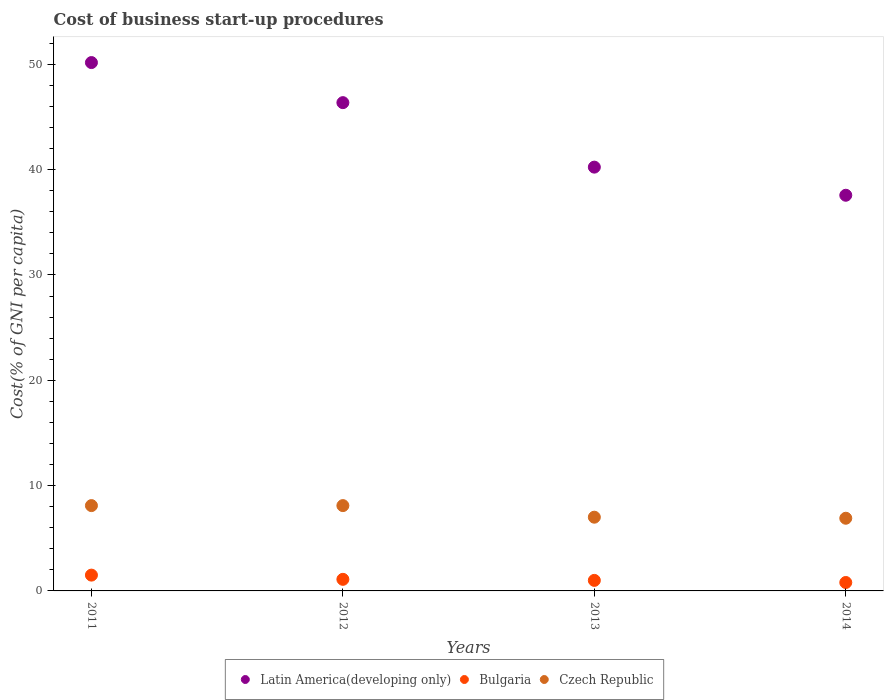Is the number of dotlines equal to the number of legend labels?
Keep it short and to the point. Yes. Across all years, what is the maximum cost of business start-up procedures in Czech Republic?
Offer a terse response. 8.1. In which year was the cost of business start-up procedures in Czech Republic maximum?
Your answer should be very brief. 2011. In which year was the cost of business start-up procedures in Latin America(developing only) minimum?
Provide a short and direct response. 2014. What is the total cost of business start-up procedures in Czech Republic in the graph?
Provide a succinct answer. 30.1. What is the difference between the cost of business start-up procedures in Bulgaria in 2013 and that in 2014?
Give a very brief answer. 0.2. What is the difference between the cost of business start-up procedures in Latin America(developing only) in 2013 and the cost of business start-up procedures in Bulgaria in 2014?
Keep it short and to the point. 39.43. What is the average cost of business start-up procedures in Czech Republic per year?
Keep it short and to the point. 7.53. In the year 2014, what is the difference between the cost of business start-up procedures in Bulgaria and cost of business start-up procedures in Latin America(developing only)?
Your response must be concise. -36.77. What is the ratio of the cost of business start-up procedures in Latin America(developing only) in 2012 to that in 2013?
Keep it short and to the point. 1.15. Is the cost of business start-up procedures in Czech Republic in 2011 less than that in 2013?
Ensure brevity in your answer.  No. Is the difference between the cost of business start-up procedures in Bulgaria in 2012 and 2014 greater than the difference between the cost of business start-up procedures in Latin America(developing only) in 2012 and 2014?
Your answer should be compact. No. What is the difference between the highest and the second highest cost of business start-up procedures in Bulgaria?
Your answer should be compact. 0.4. What is the difference between the highest and the lowest cost of business start-up procedures in Latin America(developing only)?
Your response must be concise. 12.6. In how many years, is the cost of business start-up procedures in Bulgaria greater than the average cost of business start-up procedures in Bulgaria taken over all years?
Your answer should be compact. 1. Does the cost of business start-up procedures in Bulgaria monotonically increase over the years?
Give a very brief answer. No. Is the cost of business start-up procedures in Bulgaria strictly greater than the cost of business start-up procedures in Czech Republic over the years?
Offer a very short reply. No. Is the cost of business start-up procedures in Latin America(developing only) strictly less than the cost of business start-up procedures in Bulgaria over the years?
Keep it short and to the point. No. How many dotlines are there?
Offer a very short reply. 3. How many years are there in the graph?
Ensure brevity in your answer.  4. Does the graph contain any zero values?
Your answer should be very brief. No. What is the title of the graph?
Provide a succinct answer. Cost of business start-up procedures. Does "Mauritius" appear as one of the legend labels in the graph?
Provide a short and direct response. No. What is the label or title of the X-axis?
Your answer should be compact. Years. What is the label or title of the Y-axis?
Provide a short and direct response. Cost(% of GNI per capita). What is the Cost(% of GNI per capita) in Latin America(developing only) in 2011?
Your response must be concise. 50.16. What is the Cost(% of GNI per capita) in Czech Republic in 2011?
Ensure brevity in your answer.  8.1. What is the Cost(% of GNI per capita) in Latin America(developing only) in 2012?
Offer a very short reply. 46.36. What is the Cost(% of GNI per capita) of Bulgaria in 2012?
Your response must be concise. 1.1. What is the Cost(% of GNI per capita) of Czech Republic in 2012?
Offer a terse response. 8.1. What is the Cost(% of GNI per capita) in Latin America(developing only) in 2013?
Provide a short and direct response. 40.23. What is the Cost(% of GNI per capita) in Bulgaria in 2013?
Provide a succinct answer. 1. What is the Cost(% of GNI per capita) of Latin America(developing only) in 2014?
Your response must be concise. 37.57. What is the Cost(% of GNI per capita) of Bulgaria in 2014?
Keep it short and to the point. 0.8. Across all years, what is the maximum Cost(% of GNI per capita) in Latin America(developing only)?
Provide a short and direct response. 50.16. Across all years, what is the minimum Cost(% of GNI per capita) in Latin America(developing only)?
Offer a terse response. 37.57. Across all years, what is the minimum Cost(% of GNI per capita) in Czech Republic?
Your answer should be compact. 6.9. What is the total Cost(% of GNI per capita) in Latin America(developing only) in the graph?
Your response must be concise. 174.32. What is the total Cost(% of GNI per capita) of Czech Republic in the graph?
Provide a short and direct response. 30.1. What is the difference between the Cost(% of GNI per capita) of Latin America(developing only) in 2011 and that in 2012?
Offer a very short reply. 3.8. What is the difference between the Cost(% of GNI per capita) in Czech Republic in 2011 and that in 2012?
Keep it short and to the point. 0. What is the difference between the Cost(% of GNI per capita) in Latin America(developing only) in 2011 and that in 2013?
Your answer should be very brief. 9.93. What is the difference between the Cost(% of GNI per capita) of Czech Republic in 2011 and that in 2013?
Offer a terse response. 1.1. What is the difference between the Cost(% of GNI per capita) of Latin America(developing only) in 2011 and that in 2014?
Provide a succinct answer. 12.6. What is the difference between the Cost(% of GNI per capita) of Latin America(developing only) in 2012 and that in 2013?
Offer a terse response. 6.12. What is the difference between the Cost(% of GNI per capita) of Latin America(developing only) in 2012 and that in 2014?
Offer a very short reply. 8.79. What is the difference between the Cost(% of GNI per capita) in Czech Republic in 2012 and that in 2014?
Provide a succinct answer. 1.2. What is the difference between the Cost(% of GNI per capita) of Latin America(developing only) in 2013 and that in 2014?
Provide a short and direct response. 2.67. What is the difference between the Cost(% of GNI per capita) of Czech Republic in 2013 and that in 2014?
Your response must be concise. 0.1. What is the difference between the Cost(% of GNI per capita) in Latin America(developing only) in 2011 and the Cost(% of GNI per capita) in Bulgaria in 2012?
Give a very brief answer. 49.06. What is the difference between the Cost(% of GNI per capita) of Latin America(developing only) in 2011 and the Cost(% of GNI per capita) of Czech Republic in 2012?
Give a very brief answer. 42.06. What is the difference between the Cost(% of GNI per capita) in Bulgaria in 2011 and the Cost(% of GNI per capita) in Czech Republic in 2012?
Your answer should be compact. -6.6. What is the difference between the Cost(% of GNI per capita) of Latin America(developing only) in 2011 and the Cost(% of GNI per capita) of Bulgaria in 2013?
Ensure brevity in your answer.  49.16. What is the difference between the Cost(% of GNI per capita) in Latin America(developing only) in 2011 and the Cost(% of GNI per capita) in Czech Republic in 2013?
Give a very brief answer. 43.16. What is the difference between the Cost(% of GNI per capita) in Latin America(developing only) in 2011 and the Cost(% of GNI per capita) in Bulgaria in 2014?
Your answer should be compact. 49.36. What is the difference between the Cost(% of GNI per capita) of Latin America(developing only) in 2011 and the Cost(% of GNI per capita) of Czech Republic in 2014?
Give a very brief answer. 43.26. What is the difference between the Cost(% of GNI per capita) of Latin America(developing only) in 2012 and the Cost(% of GNI per capita) of Bulgaria in 2013?
Your answer should be very brief. 45.36. What is the difference between the Cost(% of GNI per capita) of Latin America(developing only) in 2012 and the Cost(% of GNI per capita) of Czech Republic in 2013?
Your response must be concise. 39.36. What is the difference between the Cost(% of GNI per capita) of Latin America(developing only) in 2012 and the Cost(% of GNI per capita) of Bulgaria in 2014?
Your answer should be very brief. 45.56. What is the difference between the Cost(% of GNI per capita) of Latin America(developing only) in 2012 and the Cost(% of GNI per capita) of Czech Republic in 2014?
Your answer should be compact. 39.46. What is the difference between the Cost(% of GNI per capita) of Latin America(developing only) in 2013 and the Cost(% of GNI per capita) of Bulgaria in 2014?
Offer a very short reply. 39.43. What is the difference between the Cost(% of GNI per capita) of Latin America(developing only) in 2013 and the Cost(% of GNI per capita) of Czech Republic in 2014?
Ensure brevity in your answer.  33.33. What is the average Cost(% of GNI per capita) of Latin America(developing only) per year?
Ensure brevity in your answer.  43.58. What is the average Cost(% of GNI per capita) of Bulgaria per year?
Your answer should be compact. 1.1. What is the average Cost(% of GNI per capita) in Czech Republic per year?
Your answer should be very brief. 7.53. In the year 2011, what is the difference between the Cost(% of GNI per capita) of Latin America(developing only) and Cost(% of GNI per capita) of Bulgaria?
Offer a very short reply. 48.66. In the year 2011, what is the difference between the Cost(% of GNI per capita) of Latin America(developing only) and Cost(% of GNI per capita) of Czech Republic?
Provide a short and direct response. 42.06. In the year 2011, what is the difference between the Cost(% of GNI per capita) of Bulgaria and Cost(% of GNI per capita) of Czech Republic?
Offer a terse response. -6.6. In the year 2012, what is the difference between the Cost(% of GNI per capita) in Latin America(developing only) and Cost(% of GNI per capita) in Bulgaria?
Offer a very short reply. 45.26. In the year 2012, what is the difference between the Cost(% of GNI per capita) of Latin America(developing only) and Cost(% of GNI per capita) of Czech Republic?
Offer a terse response. 38.26. In the year 2012, what is the difference between the Cost(% of GNI per capita) in Bulgaria and Cost(% of GNI per capita) in Czech Republic?
Offer a terse response. -7. In the year 2013, what is the difference between the Cost(% of GNI per capita) of Latin America(developing only) and Cost(% of GNI per capita) of Bulgaria?
Your answer should be compact. 39.23. In the year 2013, what is the difference between the Cost(% of GNI per capita) in Latin America(developing only) and Cost(% of GNI per capita) in Czech Republic?
Keep it short and to the point. 33.23. In the year 2014, what is the difference between the Cost(% of GNI per capita) of Latin America(developing only) and Cost(% of GNI per capita) of Bulgaria?
Offer a very short reply. 36.77. In the year 2014, what is the difference between the Cost(% of GNI per capita) in Latin America(developing only) and Cost(% of GNI per capita) in Czech Republic?
Give a very brief answer. 30.67. What is the ratio of the Cost(% of GNI per capita) in Latin America(developing only) in 2011 to that in 2012?
Offer a terse response. 1.08. What is the ratio of the Cost(% of GNI per capita) of Bulgaria in 2011 to that in 2012?
Give a very brief answer. 1.36. What is the ratio of the Cost(% of GNI per capita) in Czech Republic in 2011 to that in 2012?
Make the answer very short. 1. What is the ratio of the Cost(% of GNI per capita) in Latin America(developing only) in 2011 to that in 2013?
Offer a very short reply. 1.25. What is the ratio of the Cost(% of GNI per capita) of Czech Republic in 2011 to that in 2013?
Your response must be concise. 1.16. What is the ratio of the Cost(% of GNI per capita) in Latin America(developing only) in 2011 to that in 2014?
Your response must be concise. 1.34. What is the ratio of the Cost(% of GNI per capita) in Bulgaria in 2011 to that in 2014?
Make the answer very short. 1.88. What is the ratio of the Cost(% of GNI per capita) of Czech Republic in 2011 to that in 2014?
Give a very brief answer. 1.17. What is the ratio of the Cost(% of GNI per capita) in Latin America(developing only) in 2012 to that in 2013?
Make the answer very short. 1.15. What is the ratio of the Cost(% of GNI per capita) of Bulgaria in 2012 to that in 2013?
Ensure brevity in your answer.  1.1. What is the ratio of the Cost(% of GNI per capita) in Czech Republic in 2012 to that in 2013?
Your answer should be very brief. 1.16. What is the ratio of the Cost(% of GNI per capita) of Latin America(developing only) in 2012 to that in 2014?
Ensure brevity in your answer.  1.23. What is the ratio of the Cost(% of GNI per capita) of Bulgaria in 2012 to that in 2014?
Keep it short and to the point. 1.38. What is the ratio of the Cost(% of GNI per capita) in Czech Republic in 2012 to that in 2014?
Provide a short and direct response. 1.17. What is the ratio of the Cost(% of GNI per capita) in Latin America(developing only) in 2013 to that in 2014?
Offer a very short reply. 1.07. What is the ratio of the Cost(% of GNI per capita) of Bulgaria in 2013 to that in 2014?
Offer a terse response. 1.25. What is the ratio of the Cost(% of GNI per capita) in Czech Republic in 2013 to that in 2014?
Offer a terse response. 1.01. What is the difference between the highest and the second highest Cost(% of GNI per capita) in Latin America(developing only)?
Provide a succinct answer. 3.8. What is the difference between the highest and the second highest Cost(% of GNI per capita) of Bulgaria?
Keep it short and to the point. 0.4. What is the difference between the highest and the lowest Cost(% of GNI per capita) in Latin America(developing only)?
Offer a very short reply. 12.6. 